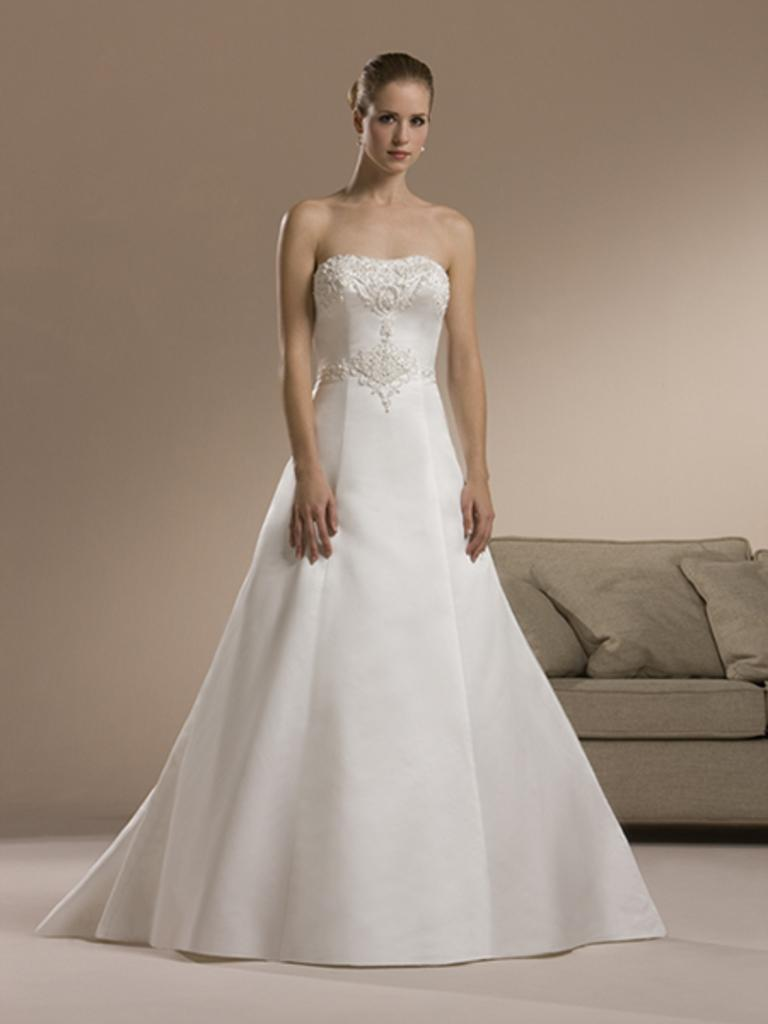Where was the image taken? The image was taken inside a room. Who is present in the image? There is a woman in the image. What is the woman doing in the image? The woman is standing. What is the woman wearing in the image? The woman is wearing a white dress. What can be seen in the background of the image? There is a sofa in the background of the image. What type of government is depicted in the image? There is no depiction of a government in the image; it features a woman standing inside a room. What kind of bushes can be seen in the image? There are no bushes present in the image; it was taken inside a room. 